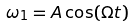<formula> <loc_0><loc_0><loc_500><loc_500>\omega _ { 1 } = A \cos ( \Omega t )</formula> 